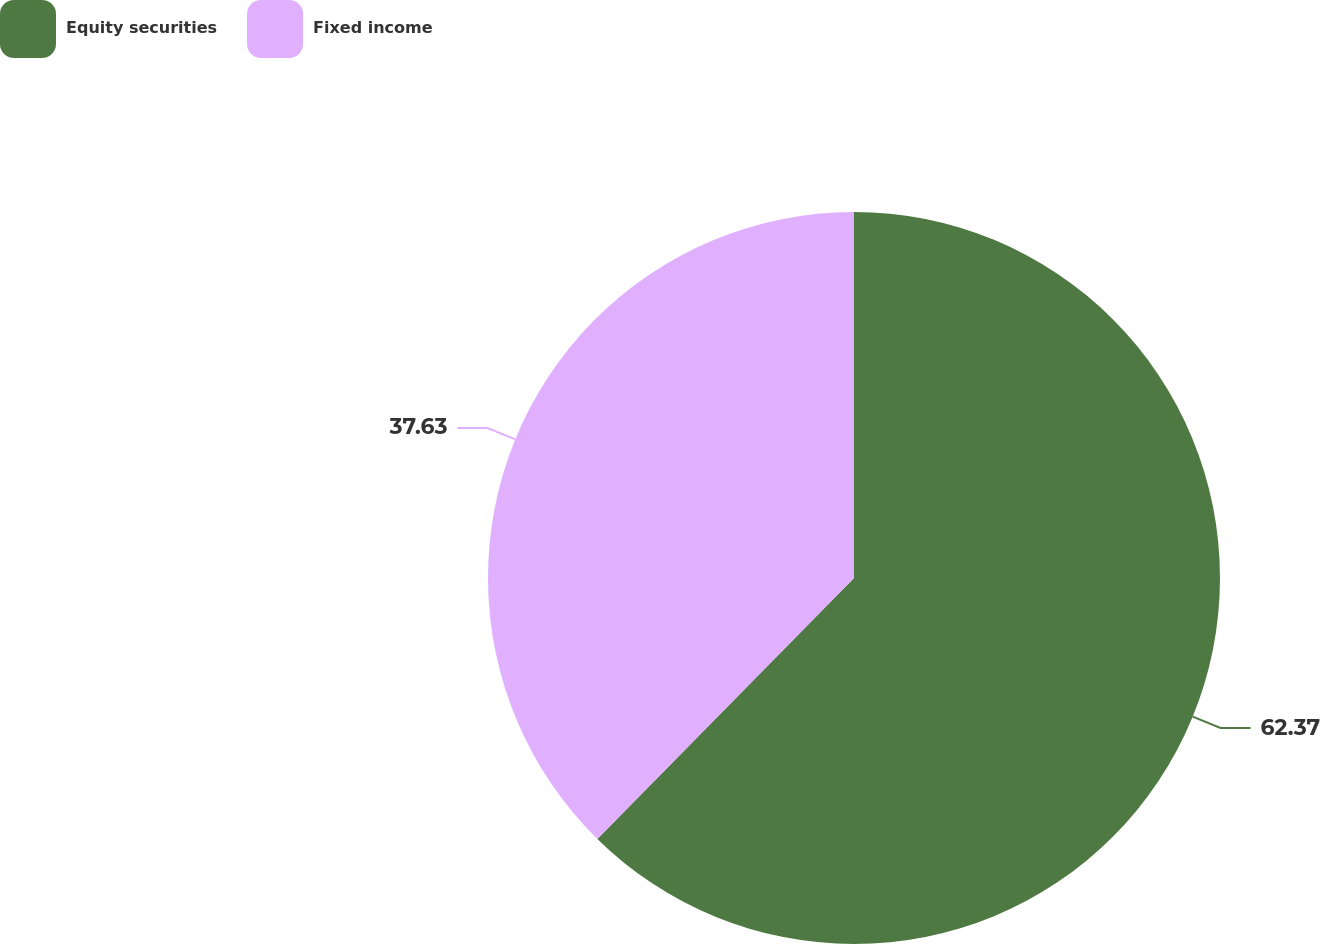<chart> <loc_0><loc_0><loc_500><loc_500><pie_chart><fcel>Equity securities<fcel>Fixed income<nl><fcel>62.37%<fcel>37.63%<nl></chart> 